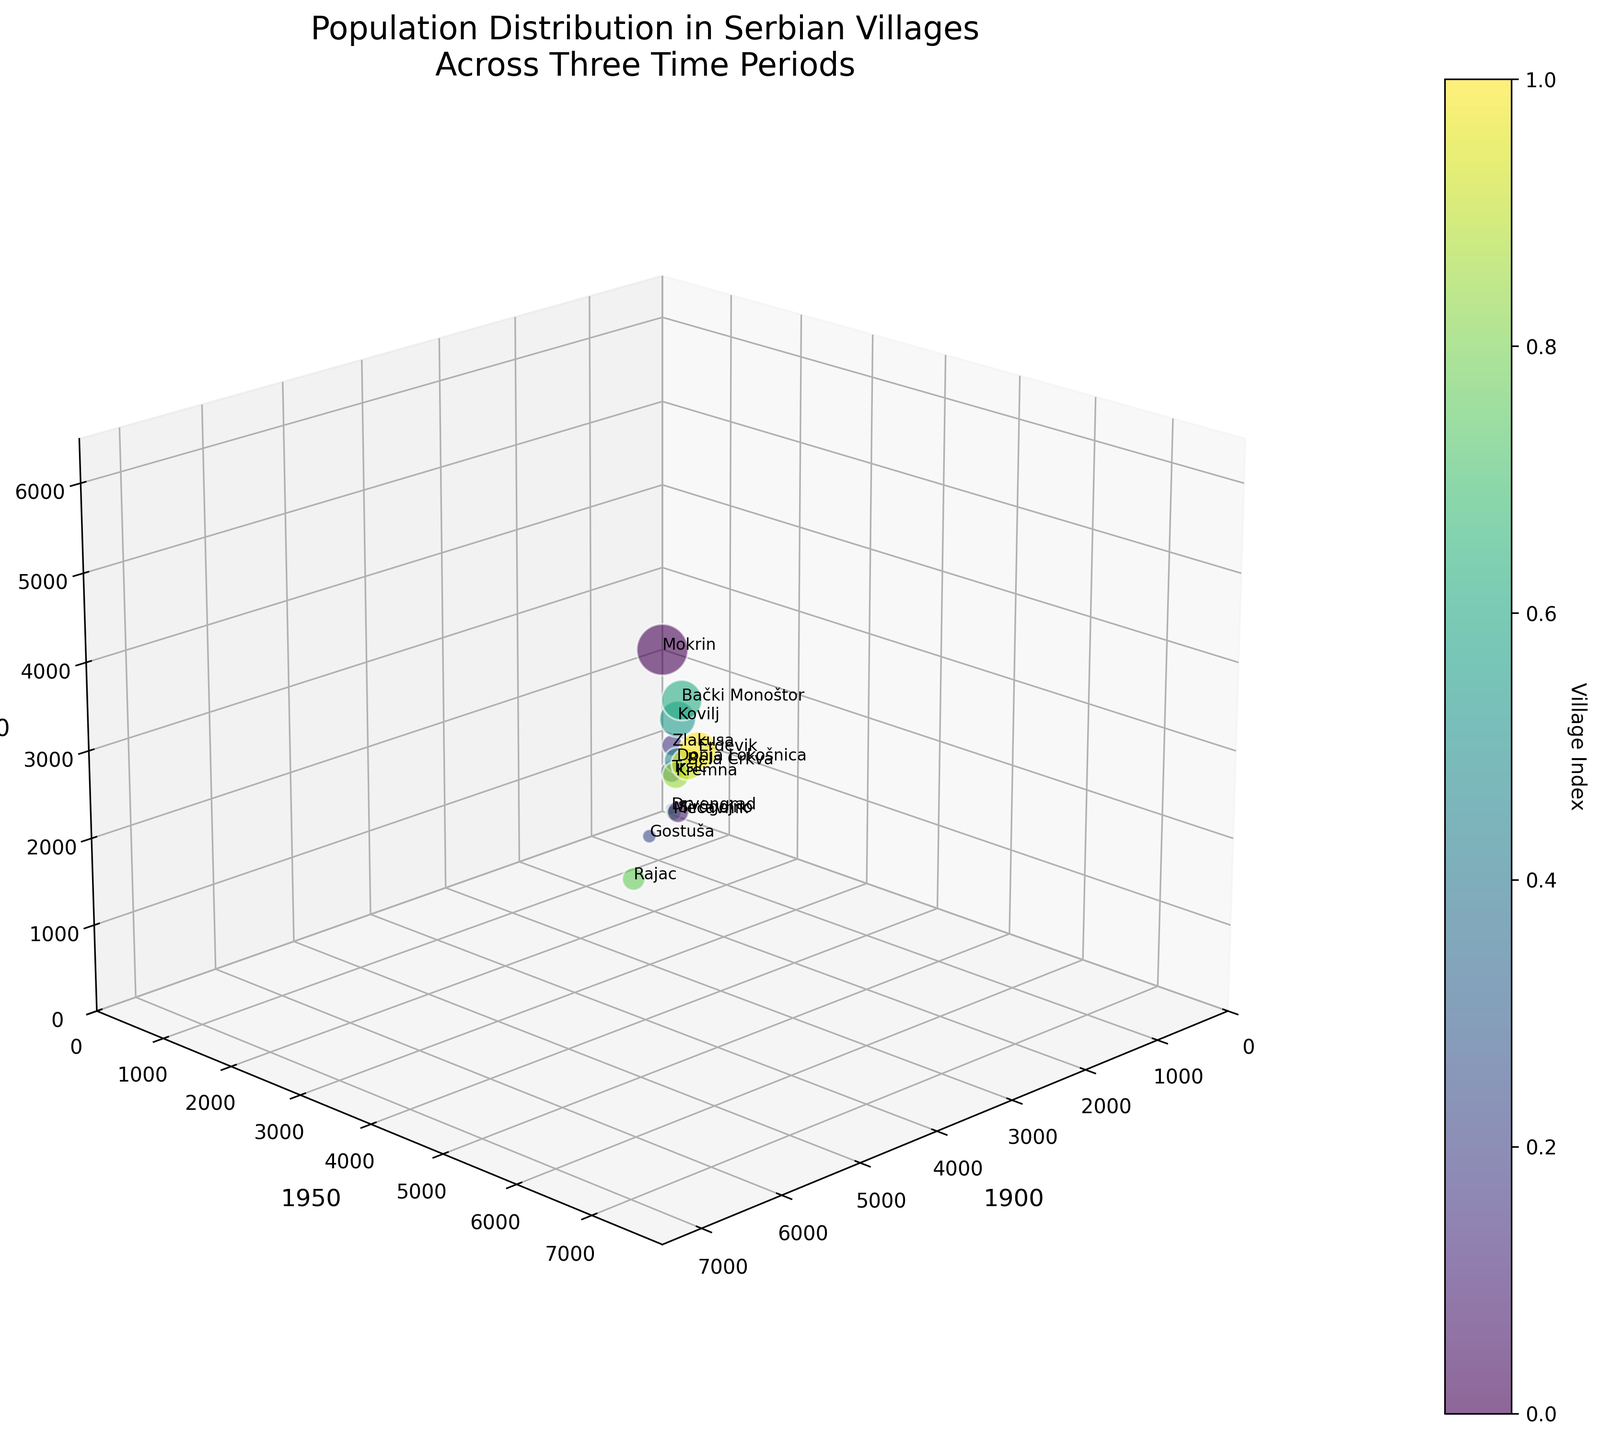What is the title of the figure? The title of the figure is located at the top and reads "Population Distribution in Serbian Villages Across Three Time Periods."
Answer: Population Distribution in Serbian Villages Across Three Time Periods Which axis represents the population in 1950? The axis labeled with "1950" represents the population in that year. It is the vertical (y) axis.
Answer: The vertical axis (y-axis) Which village had the largest population in 1900? To find the village with the largest population in 1900, look at the x-axis for the highest data point. Mokrin has the largest population in 1900.
Answer: Mokrin Which two villages had a decrease in population from 1950 to 2000? Identify villages by comparing their y-axis (1950 population) and z-axis (2000 population) values. Mokrin and Sirogojno show a decrease from 1950 to 2000.
Answer: Mokrin, Sirogojno Which village saw the most significant population decline from 1900 to 2000? To find the village with the most significant population decline, compare the values on the x-axis (1900) and z-axis (2000). Rajac shows a decline from 2000 to 300, a difference of 1700.
Answer: Rajac Which villages have seen a continual decline from 1900 to 2000? Look at the values on x, y, and z-axes for villages where the population decreases in both intervals (1900-1950 and 1950-2000). Mokrin, Sirogojno, Gostuša, Drvengrad, Mećavnik, Rajac, and Kremna show continuous decline.
Answer: Mokrin, Sirogojno, Gostuša, Drvengrad, Mećavnik, Rajac, Kremna What is the color-coding based on in the figure? Examine the color scheme and the color bar; it is based on the Village Index, which assigns different colors to different villages.
Answer: Village Index Which village had the smallest population in 2000? Check the z-axis for the smallest value to find the village with the smallest population in 2000. Gostuša has a population of 100 in 2000.
Answer: Gostuša Which village had the largest population in all three time periods combined? Sum the populations for each village across all three time periods and compare. Mokrin had the highest combined population: 6800 (1900) + 7200 (1950) + 5900 (2000) = 19900.
Answer: Mokrin How do the population trends of Bela Crkva and Erdevik differ over the three time periods? Compare the values of Bela Crkva and Erdevik across x, y, and z-axes. Bela Crkva grows from 2500 (1900) to 3000 (1950), then declines to 2200 (2000). Erdevik grows consistently from 3500 (1900) to 4200 (1950) and then reduces to 3000 (2000). Bela Crkva peaks in 1950 and then declines, whereas Erdevik grows significantly until 1950 and then reduces in 2000.
Answer: Bela Crkva shows growth then decline, Erdevik shows significant growth then slight reduction 